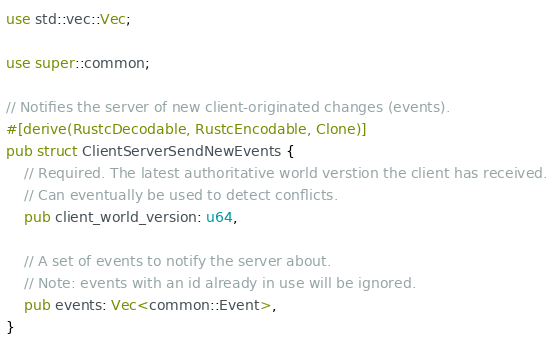<code> <loc_0><loc_0><loc_500><loc_500><_Rust_>use std::vec::Vec;

use super::common;

// Notifies the server of new client-originated changes (events).
#[derive(RustcDecodable, RustcEncodable, Clone)]
pub struct ClientServerSendNewEvents {
    // Required. The latest authoritative world verstion the client has received.
    // Can eventually be used to detect conflicts.
    pub client_world_version: u64,

    // A set of events to notify the server about.
    // Note: events with an id already in use will be ignored.
    pub events: Vec<common::Event>,
}
</code> 